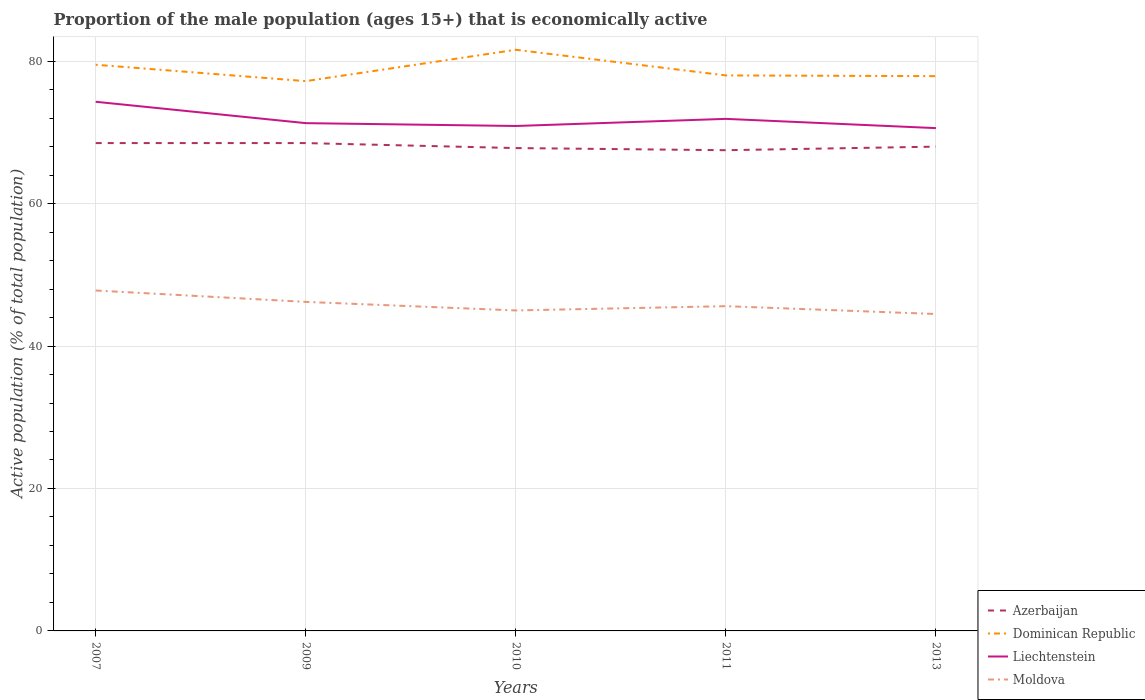How many different coloured lines are there?
Offer a terse response. 4. Is the number of lines equal to the number of legend labels?
Your response must be concise. Yes. Across all years, what is the maximum proportion of the male population that is economically active in Azerbaijan?
Your response must be concise. 67.5. In which year was the proportion of the male population that is economically active in Moldova maximum?
Ensure brevity in your answer.  2013. What is the total proportion of the male population that is economically active in Dominican Republic in the graph?
Provide a short and direct response. -4.4. What is the difference between the highest and the second highest proportion of the male population that is economically active in Liechtenstein?
Provide a short and direct response. 3.7. What is the difference between the highest and the lowest proportion of the male population that is economically active in Liechtenstein?
Your answer should be very brief. 2. Is the proportion of the male population that is economically active in Azerbaijan strictly greater than the proportion of the male population that is economically active in Dominican Republic over the years?
Offer a terse response. Yes. Does the graph contain grids?
Your answer should be very brief. Yes. Where does the legend appear in the graph?
Offer a very short reply. Bottom right. How many legend labels are there?
Your answer should be very brief. 4. How are the legend labels stacked?
Offer a terse response. Vertical. What is the title of the graph?
Your response must be concise. Proportion of the male population (ages 15+) that is economically active. Does "Chile" appear as one of the legend labels in the graph?
Offer a terse response. No. What is the label or title of the X-axis?
Make the answer very short. Years. What is the label or title of the Y-axis?
Your response must be concise. Active population (% of total population). What is the Active population (% of total population) in Azerbaijan in 2007?
Offer a terse response. 68.5. What is the Active population (% of total population) of Dominican Republic in 2007?
Your answer should be very brief. 79.5. What is the Active population (% of total population) in Liechtenstein in 2007?
Offer a very short reply. 74.3. What is the Active population (% of total population) of Moldova in 2007?
Give a very brief answer. 47.8. What is the Active population (% of total population) in Azerbaijan in 2009?
Your answer should be compact. 68.5. What is the Active population (% of total population) of Dominican Republic in 2009?
Offer a terse response. 77.2. What is the Active population (% of total population) in Liechtenstein in 2009?
Keep it short and to the point. 71.3. What is the Active population (% of total population) of Moldova in 2009?
Offer a very short reply. 46.2. What is the Active population (% of total population) in Azerbaijan in 2010?
Provide a succinct answer. 67.8. What is the Active population (% of total population) in Dominican Republic in 2010?
Your answer should be compact. 81.6. What is the Active population (% of total population) in Liechtenstein in 2010?
Keep it short and to the point. 70.9. What is the Active population (% of total population) in Azerbaijan in 2011?
Make the answer very short. 67.5. What is the Active population (% of total population) of Liechtenstein in 2011?
Your answer should be very brief. 71.9. What is the Active population (% of total population) in Moldova in 2011?
Your answer should be very brief. 45.6. What is the Active population (% of total population) in Dominican Republic in 2013?
Keep it short and to the point. 77.9. What is the Active population (% of total population) of Liechtenstein in 2013?
Your response must be concise. 70.6. What is the Active population (% of total population) of Moldova in 2013?
Offer a terse response. 44.5. Across all years, what is the maximum Active population (% of total population) in Azerbaijan?
Your answer should be very brief. 68.5. Across all years, what is the maximum Active population (% of total population) of Dominican Republic?
Your answer should be compact. 81.6. Across all years, what is the maximum Active population (% of total population) of Liechtenstein?
Make the answer very short. 74.3. Across all years, what is the maximum Active population (% of total population) in Moldova?
Provide a short and direct response. 47.8. Across all years, what is the minimum Active population (% of total population) of Azerbaijan?
Provide a short and direct response. 67.5. Across all years, what is the minimum Active population (% of total population) in Dominican Republic?
Your answer should be very brief. 77.2. Across all years, what is the minimum Active population (% of total population) in Liechtenstein?
Your answer should be compact. 70.6. Across all years, what is the minimum Active population (% of total population) in Moldova?
Your answer should be compact. 44.5. What is the total Active population (% of total population) in Azerbaijan in the graph?
Make the answer very short. 340.3. What is the total Active population (% of total population) in Dominican Republic in the graph?
Your answer should be compact. 394.2. What is the total Active population (% of total population) of Liechtenstein in the graph?
Offer a very short reply. 359. What is the total Active population (% of total population) in Moldova in the graph?
Provide a succinct answer. 229.1. What is the difference between the Active population (% of total population) of Dominican Republic in 2007 and that in 2009?
Ensure brevity in your answer.  2.3. What is the difference between the Active population (% of total population) of Liechtenstein in 2007 and that in 2009?
Keep it short and to the point. 3. What is the difference between the Active population (% of total population) in Moldova in 2007 and that in 2009?
Provide a succinct answer. 1.6. What is the difference between the Active population (% of total population) of Dominican Republic in 2007 and that in 2010?
Offer a terse response. -2.1. What is the difference between the Active population (% of total population) in Liechtenstein in 2007 and that in 2010?
Offer a terse response. 3.4. What is the difference between the Active population (% of total population) of Dominican Republic in 2007 and that in 2011?
Offer a very short reply. 1.5. What is the difference between the Active population (% of total population) of Moldova in 2007 and that in 2011?
Keep it short and to the point. 2.2. What is the difference between the Active population (% of total population) of Azerbaijan in 2007 and that in 2013?
Provide a short and direct response. 0.5. What is the difference between the Active population (% of total population) of Dominican Republic in 2007 and that in 2013?
Your response must be concise. 1.6. What is the difference between the Active population (% of total population) of Liechtenstein in 2007 and that in 2013?
Provide a succinct answer. 3.7. What is the difference between the Active population (% of total population) in Dominican Republic in 2009 and that in 2010?
Offer a very short reply. -4.4. What is the difference between the Active population (% of total population) in Azerbaijan in 2009 and that in 2011?
Offer a very short reply. 1. What is the difference between the Active population (% of total population) of Dominican Republic in 2009 and that in 2011?
Your response must be concise. -0.8. What is the difference between the Active population (% of total population) of Moldova in 2009 and that in 2011?
Offer a very short reply. 0.6. What is the difference between the Active population (% of total population) in Azerbaijan in 2009 and that in 2013?
Your answer should be very brief. 0.5. What is the difference between the Active population (% of total population) of Dominican Republic in 2010 and that in 2011?
Make the answer very short. 3.6. What is the difference between the Active population (% of total population) of Liechtenstein in 2010 and that in 2011?
Provide a succinct answer. -1. What is the difference between the Active population (% of total population) of Azerbaijan in 2010 and that in 2013?
Provide a short and direct response. -0.2. What is the difference between the Active population (% of total population) of Dominican Republic in 2010 and that in 2013?
Give a very brief answer. 3.7. What is the difference between the Active population (% of total population) of Liechtenstein in 2010 and that in 2013?
Your answer should be compact. 0.3. What is the difference between the Active population (% of total population) of Dominican Republic in 2011 and that in 2013?
Make the answer very short. 0.1. What is the difference between the Active population (% of total population) of Azerbaijan in 2007 and the Active population (% of total population) of Moldova in 2009?
Ensure brevity in your answer.  22.3. What is the difference between the Active population (% of total population) of Dominican Republic in 2007 and the Active population (% of total population) of Moldova in 2009?
Offer a very short reply. 33.3. What is the difference between the Active population (% of total population) of Liechtenstein in 2007 and the Active population (% of total population) of Moldova in 2009?
Your answer should be very brief. 28.1. What is the difference between the Active population (% of total population) of Azerbaijan in 2007 and the Active population (% of total population) of Liechtenstein in 2010?
Provide a succinct answer. -2.4. What is the difference between the Active population (% of total population) of Azerbaijan in 2007 and the Active population (% of total population) of Moldova in 2010?
Provide a short and direct response. 23.5. What is the difference between the Active population (% of total population) in Dominican Republic in 2007 and the Active population (% of total population) in Liechtenstein in 2010?
Offer a terse response. 8.6. What is the difference between the Active population (% of total population) of Dominican Republic in 2007 and the Active population (% of total population) of Moldova in 2010?
Provide a short and direct response. 34.5. What is the difference between the Active population (% of total population) of Liechtenstein in 2007 and the Active population (% of total population) of Moldova in 2010?
Give a very brief answer. 29.3. What is the difference between the Active population (% of total population) in Azerbaijan in 2007 and the Active population (% of total population) in Liechtenstein in 2011?
Offer a very short reply. -3.4. What is the difference between the Active population (% of total population) in Azerbaijan in 2007 and the Active population (% of total population) in Moldova in 2011?
Offer a terse response. 22.9. What is the difference between the Active population (% of total population) of Dominican Republic in 2007 and the Active population (% of total population) of Liechtenstein in 2011?
Your answer should be compact. 7.6. What is the difference between the Active population (% of total population) of Dominican Republic in 2007 and the Active population (% of total population) of Moldova in 2011?
Your answer should be compact. 33.9. What is the difference between the Active population (% of total population) in Liechtenstein in 2007 and the Active population (% of total population) in Moldova in 2011?
Offer a terse response. 28.7. What is the difference between the Active population (% of total population) in Azerbaijan in 2007 and the Active population (% of total population) in Dominican Republic in 2013?
Provide a succinct answer. -9.4. What is the difference between the Active population (% of total population) of Azerbaijan in 2007 and the Active population (% of total population) of Liechtenstein in 2013?
Give a very brief answer. -2.1. What is the difference between the Active population (% of total population) of Azerbaijan in 2007 and the Active population (% of total population) of Moldova in 2013?
Give a very brief answer. 24. What is the difference between the Active population (% of total population) of Dominican Republic in 2007 and the Active population (% of total population) of Liechtenstein in 2013?
Your answer should be compact. 8.9. What is the difference between the Active population (% of total population) of Dominican Republic in 2007 and the Active population (% of total population) of Moldova in 2013?
Give a very brief answer. 35. What is the difference between the Active population (% of total population) of Liechtenstein in 2007 and the Active population (% of total population) of Moldova in 2013?
Give a very brief answer. 29.8. What is the difference between the Active population (% of total population) in Azerbaijan in 2009 and the Active population (% of total population) in Liechtenstein in 2010?
Your answer should be very brief. -2.4. What is the difference between the Active population (% of total population) of Azerbaijan in 2009 and the Active population (% of total population) of Moldova in 2010?
Offer a very short reply. 23.5. What is the difference between the Active population (% of total population) in Dominican Republic in 2009 and the Active population (% of total population) in Liechtenstein in 2010?
Make the answer very short. 6.3. What is the difference between the Active population (% of total population) in Dominican Republic in 2009 and the Active population (% of total population) in Moldova in 2010?
Your response must be concise. 32.2. What is the difference between the Active population (% of total population) in Liechtenstein in 2009 and the Active population (% of total population) in Moldova in 2010?
Your answer should be very brief. 26.3. What is the difference between the Active population (% of total population) in Azerbaijan in 2009 and the Active population (% of total population) in Liechtenstein in 2011?
Offer a very short reply. -3.4. What is the difference between the Active population (% of total population) of Azerbaijan in 2009 and the Active population (% of total population) of Moldova in 2011?
Provide a short and direct response. 22.9. What is the difference between the Active population (% of total population) of Dominican Republic in 2009 and the Active population (% of total population) of Liechtenstein in 2011?
Make the answer very short. 5.3. What is the difference between the Active population (% of total population) of Dominican Republic in 2009 and the Active population (% of total population) of Moldova in 2011?
Keep it short and to the point. 31.6. What is the difference between the Active population (% of total population) of Liechtenstein in 2009 and the Active population (% of total population) of Moldova in 2011?
Your answer should be compact. 25.7. What is the difference between the Active population (% of total population) of Azerbaijan in 2009 and the Active population (% of total population) of Liechtenstein in 2013?
Your answer should be compact. -2.1. What is the difference between the Active population (% of total population) in Dominican Republic in 2009 and the Active population (% of total population) in Moldova in 2013?
Provide a succinct answer. 32.7. What is the difference between the Active population (% of total population) of Liechtenstein in 2009 and the Active population (% of total population) of Moldova in 2013?
Make the answer very short. 26.8. What is the difference between the Active population (% of total population) in Azerbaijan in 2010 and the Active population (% of total population) in Liechtenstein in 2011?
Ensure brevity in your answer.  -4.1. What is the difference between the Active population (% of total population) in Dominican Republic in 2010 and the Active population (% of total population) in Liechtenstein in 2011?
Offer a very short reply. 9.7. What is the difference between the Active population (% of total population) of Dominican Republic in 2010 and the Active population (% of total population) of Moldova in 2011?
Your answer should be compact. 36. What is the difference between the Active population (% of total population) in Liechtenstein in 2010 and the Active population (% of total population) in Moldova in 2011?
Keep it short and to the point. 25.3. What is the difference between the Active population (% of total population) of Azerbaijan in 2010 and the Active population (% of total population) of Liechtenstein in 2013?
Provide a short and direct response. -2.8. What is the difference between the Active population (% of total population) in Azerbaijan in 2010 and the Active population (% of total population) in Moldova in 2013?
Offer a terse response. 23.3. What is the difference between the Active population (% of total population) of Dominican Republic in 2010 and the Active population (% of total population) of Liechtenstein in 2013?
Keep it short and to the point. 11. What is the difference between the Active population (% of total population) in Dominican Republic in 2010 and the Active population (% of total population) in Moldova in 2013?
Your response must be concise. 37.1. What is the difference between the Active population (% of total population) of Liechtenstein in 2010 and the Active population (% of total population) of Moldova in 2013?
Your answer should be compact. 26.4. What is the difference between the Active population (% of total population) of Azerbaijan in 2011 and the Active population (% of total population) of Dominican Republic in 2013?
Offer a terse response. -10.4. What is the difference between the Active population (% of total population) of Dominican Republic in 2011 and the Active population (% of total population) of Liechtenstein in 2013?
Your response must be concise. 7.4. What is the difference between the Active population (% of total population) in Dominican Republic in 2011 and the Active population (% of total population) in Moldova in 2013?
Provide a short and direct response. 33.5. What is the difference between the Active population (% of total population) in Liechtenstein in 2011 and the Active population (% of total population) in Moldova in 2013?
Your answer should be compact. 27.4. What is the average Active population (% of total population) in Azerbaijan per year?
Your response must be concise. 68.06. What is the average Active population (% of total population) of Dominican Republic per year?
Offer a very short reply. 78.84. What is the average Active population (% of total population) in Liechtenstein per year?
Keep it short and to the point. 71.8. What is the average Active population (% of total population) in Moldova per year?
Make the answer very short. 45.82. In the year 2007, what is the difference between the Active population (% of total population) of Azerbaijan and Active population (% of total population) of Liechtenstein?
Offer a very short reply. -5.8. In the year 2007, what is the difference between the Active population (% of total population) in Azerbaijan and Active population (% of total population) in Moldova?
Make the answer very short. 20.7. In the year 2007, what is the difference between the Active population (% of total population) of Dominican Republic and Active population (% of total population) of Liechtenstein?
Offer a terse response. 5.2. In the year 2007, what is the difference between the Active population (% of total population) in Dominican Republic and Active population (% of total population) in Moldova?
Provide a succinct answer. 31.7. In the year 2009, what is the difference between the Active population (% of total population) of Azerbaijan and Active population (% of total population) of Dominican Republic?
Your answer should be compact. -8.7. In the year 2009, what is the difference between the Active population (% of total population) of Azerbaijan and Active population (% of total population) of Liechtenstein?
Offer a very short reply. -2.8. In the year 2009, what is the difference between the Active population (% of total population) of Azerbaijan and Active population (% of total population) of Moldova?
Ensure brevity in your answer.  22.3. In the year 2009, what is the difference between the Active population (% of total population) in Liechtenstein and Active population (% of total population) in Moldova?
Your response must be concise. 25.1. In the year 2010, what is the difference between the Active population (% of total population) in Azerbaijan and Active population (% of total population) in Moldova?
Provide a short and direct response. 22.8. In the year 2010, what is the difference between the Active population (% of total population) in Dominican Republic and Active population (% of total population) in Moldova?
Offer a very short reply. 36.6. In the year 2010, what is the difference between the Active population (% of total population) in Liechtenstein and Active population (% of total population) in Moldova?
Keep it short and to the point. 25.9. In the year 2011, what is the difference between the Active population (% of total population) of Azerbaijan and Active population (% of total population) of Dominican Republic?
Offer a very short reply. -10.5. In the year 2011, what is the difference between the Active population (% of total population) of Azerbaijan and Active population (% of total population) of Moldova?
Provide a succinct answer. 21.9. In the year 2011, what is the difference between the Active population (% of total population) of Dominican Republic and Active population (% of total population) of Moldova?
Your response must be concise. 32.4. In the year 2011, what is the difference between the Active population (% of total population) of Liechtenstein and Active population (% of total population) of Moldova?
Your answer should be very brief. 26.3. In the year 2013, what is the difference between the Active population (% of total population) of Azerbaijan and Active population (% of total population) of Liechtenstein?
Provide a short and direct response. -2.6. In the year 2013, what is the difference between the Active population (% of total population) in Dominican Republic and Active population (% of total population) in Liechtenstein?
Keep it short and to the point. 7.3. In the year 2013, what is the difference between the Active population (% of total population) of Dominican Republic and Active population (% of total population) of Moldova?
Provide a succinct answer. 33.4. In the year 2013, what is the difference between the Active population (% of total population) of Liechtenstein and Active population (% of total population) of Moldova?
Provide a short and direct response. 26.1. What is the ratio of the Active population (% of total population) of Azerbaijan in 2007 to that in 2009?
Ensure brevity in your answer.  1. What is the ratio of the Active population (% of total population) of Dominican Republic in 2007 to that in 2009?
Your response must be concise. 1.03. What is the ratio of the Active population (% of total population) of Liechtenstein in 2007 to that in 2009?
Your answer should be very brief. 1.04. What is the ratio of the Active population (% of total population) in Moldova in 2007 to that in 2009?
Provide a short and direct response. 1.03. What is the ratio of the Active population (% of total population) in Azerbaijan in 2007 to that in 2010?
Your answer should be very brief. 1.01. What is the ratio of the Active population (% of total population) in Dominican Republic in 2007 to that in 2010?
Make the answer very short. 0.97. What is the ratio of the Active population (% of total population) of Liechtenstein in 2007 to that in 2010?
Your answer should be very brief. 1.05. What is the ratio of the Active population (% of total population) of Moldova in 2007 to that in 2010?
Offer a terse response. 1.06. What is the ratio of the Active population (% of total population) in Azerbaijan in 2007 to that in 2011?
Your answer should be compact. 1.01. What is the ratio of the Active population (% of total population) in Dominican Republic in 2007 to that in 2011?
Give a very brief answer. 1.02. What is the ratio of the Active population (% of total population) in Liechtenstein in 2007 to that in 2011?
Give a very brief answer. 1.03. What is the ratio of the Active population (% of total population) in Moldova in 2007 to that in 2011?
Your response must be concise. 1.05. What is the ratio of the Active population (% of total population) in Azerbaijan in 2007 to that in 2013?
Give a very brief answer. 1.01. What is the ratio of the Active population (% of total population) of Dominican Republic in 2007 to that in 2013?
Provide a short and direct response. 1.02. What is the ratio of the Active population (% of total population) in Liechtenstein in 2007 to that in 2013?
Offer a very short reply. 1.05. What is the ratio of the Active population (% of total population) in Moldova in 2007 to that in 2013?
Provide a succinct answer. 1.07. What is the ratio of the Active population (% of total population) in Azerbaijan in 2009 to that in 2010?
Ensure brevity in your answer.  1.01. What is the ratio of the Active population (% of total population) in Dominican Republic in 2009 to that in 2010?
Your answer should be very brief. 0.95. What is the ratio of the Active population (% of total population) of Liechtenstein in 2009 to that in 2010?
Provide a succinct answer. 1.01. What is the ratio of the Active population (% of total population) in Moldova in 2009 to that in 2010?
Offer a very short reply. 1.03. What is the ratio of the Active population (% of total population) of Azerbaijan in 2009 to that in 2011?
Provide a succinct answer. 1.01. What is the ratio of the Active population (% of total population) of Moldova in 2009 to that in 2011?
Offer a very short reply. 1.01. What is the ratio of the Active population (% of total population) in Azerbaijan in 2009 to that in 2013?
Your answer should be compact. 1.01. What is the ratio of the Active population (% of total population) in Liechtenstein in 2009 to that in 2013?
Give a very brief answer. 1.01. What is the ratio of the Active population (% of total population) of Moldova in 2009 to that in 2013?
Offer a terse response. 1.04. What is the ratio of the Active population (% of total population) of Azerbaijan in 2010 to that in 2011?
Your answer should be very brief. 1. What is the ratio of the Active population (% of total population) of Dominican Republic in 2010 to that in 2011?
Your response must be concise. 1.05. What is the ratio of the Active population (% of total population) of Liechtenstein in 2010 to that in 2011?
Your answer should be very brief. 0.99. What is the ratio of the Active population (% of total population) in Moldova in 2010 to that in 2011?
Your answer should be compact. 0.99. What is the ratio of the Active population (% of total population) in Dominican Republic in 2010 to that in 2013?
Give a very brief answer. 1.05. What is the ratio of the Active population (% of total population) of Liechtenstein in 2010 to that in 2013?
Make the answer very short. 1. What is the ratio of the Active population (% of total population) in Moldova in 2010 to that in 2013?
Keep it short and to the point. 1.01. What is the ratio of the Active population (% of total population) in Azerbaijan in 2011 to that in 2013?
Offer a terse response. 0.99. What is the ratio of the Active population (% of total population) of Liechtenstein in 2011 to that in 2013?
Offer a terse response. 1.02. What is the ratio of the Active population (% of total population) of Moldova in 2011 to that in 2013?
Offer a terse response. 1.02. What is the difference between the highest and the second highest Active population (% of total population) of Azerbaijan?
Provide a succinct answer. 0. What is the difference between the highest and the second highest Active population (% of total population) of Liechtenstein?
Give a very brief answer. 2.4. What is the difference between the highest and the second highest Active population (% of total population) of Moldova?
Your response must be concise. 1.6. What is the difference between the highest and the lowest Active population (% of total population) in Dominican Republic?
Ensure brevity in your answer.  4.4. What is the difference between the highest and the lowest Active population (% of total population) of Liechtenstein?
Keep it short and to the point. 3.7. What is the difference between the highest and the lowest Active population (% of total population) in Moldova?
Give a very brief answer. 3.3. 